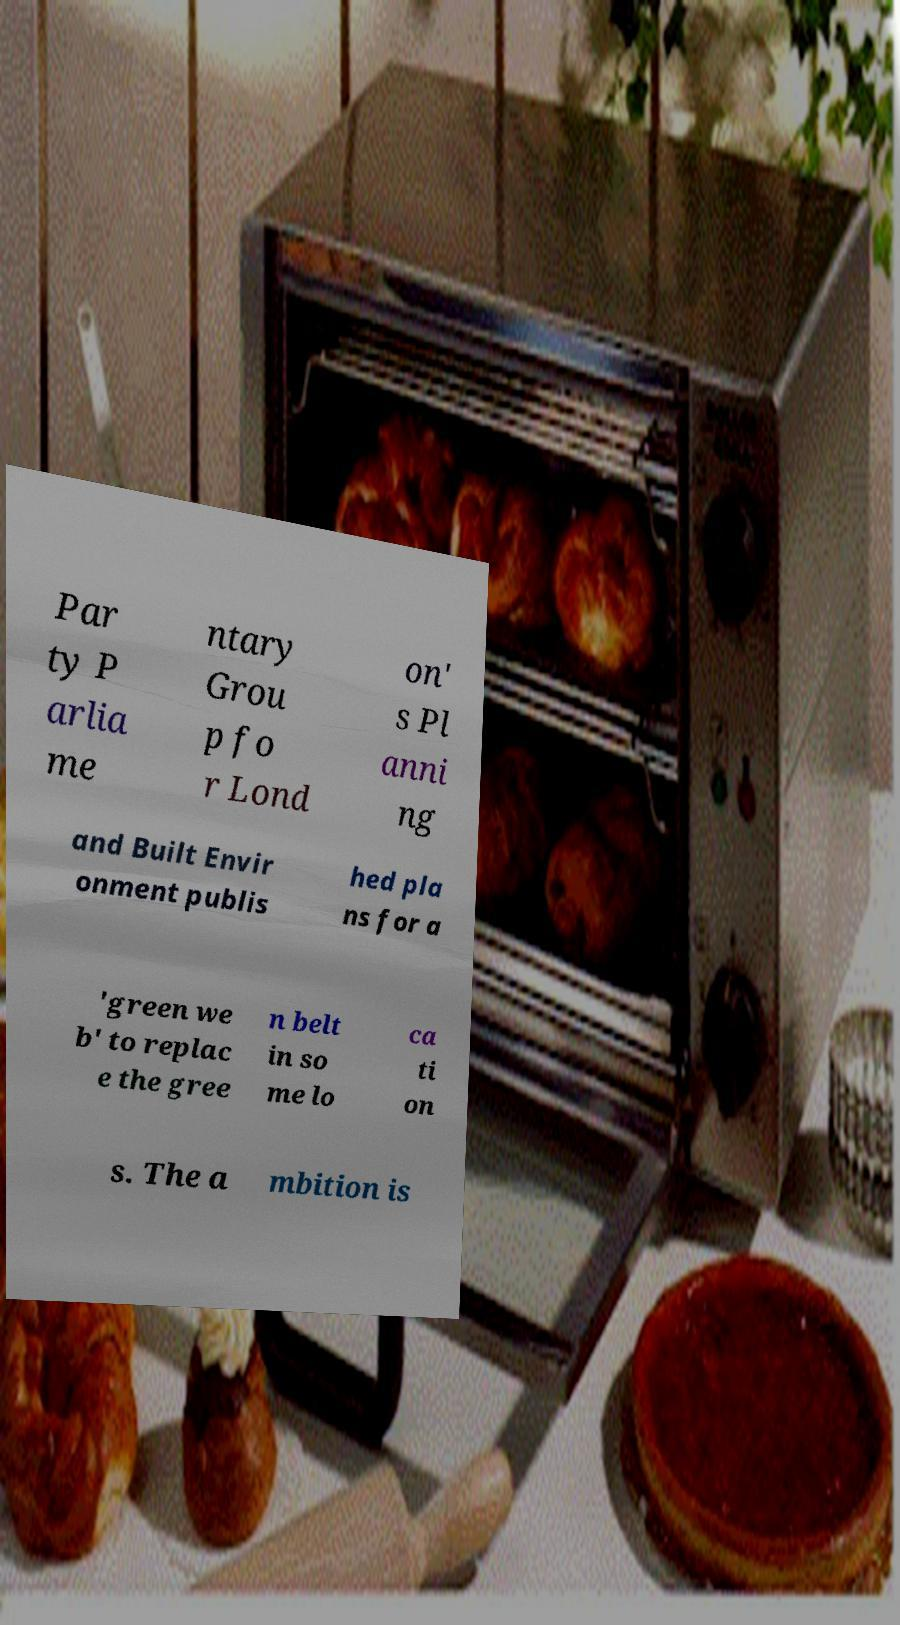I need the written content from this picture converted into text. Can you do that? Par ty P arlia me ntary Grou p fo r Lond on' s Pl anni ng and Built Envir onment publis hed pla ns for a 'green we b' to replac e the gree n belt in so me lo ca ti on s. The a mbition is 